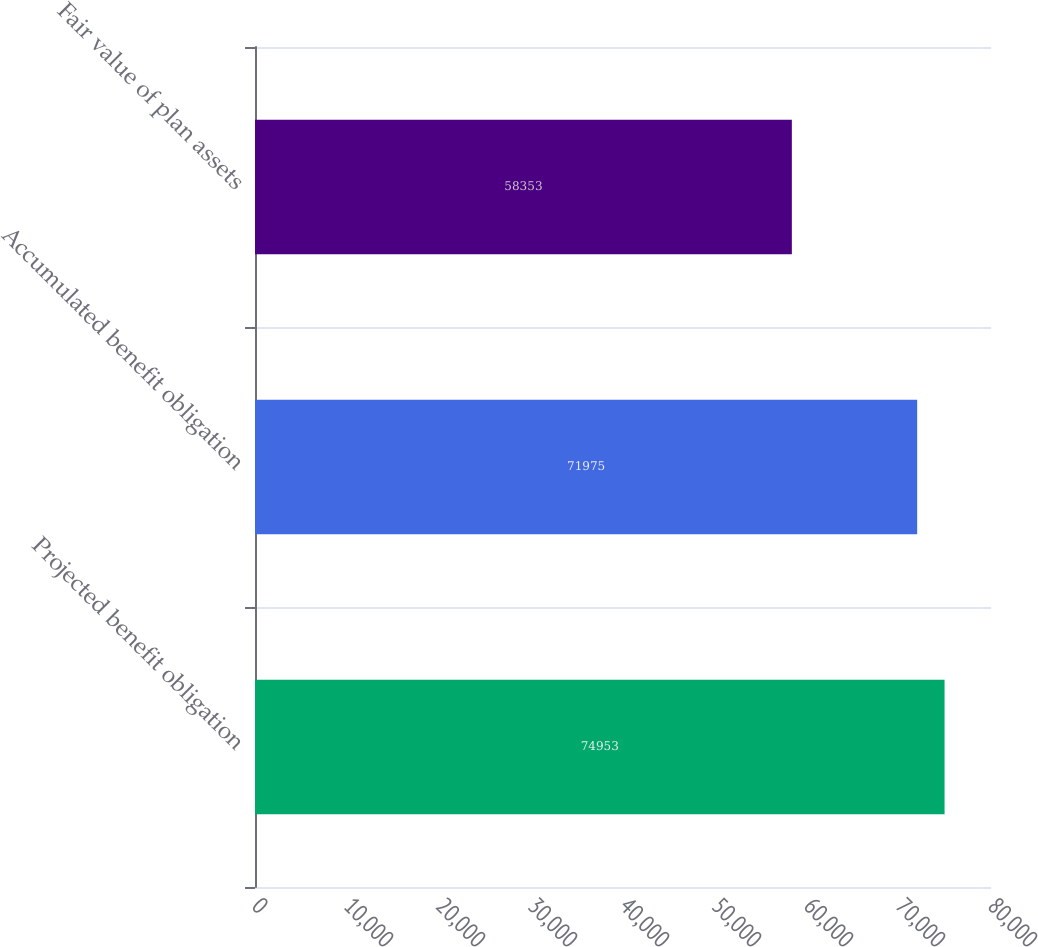<chart> <loc_0><loc_0><loc_500><loc_500><bar_chart><fcel>Projected benefit obligation<fcel>Accumulated benefit obligation<fcel>Fair value of plan assets<nl><fcel>74953<fcel>71975<fcel>58353<nl></chart> 